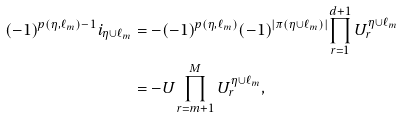<formula> <loc_0><loc_0><loc_500><loc_500>( - 1 ) ^ { p ( \eta , \ell _ { m } ) - 1 } i _ { \eta \cup \ell _ { m } } & = - ( - 1 ) ^ { p ( \eta , \ell _ { m } ) } ( - 1 ) ^ { | \pi ( \eta \cup \ell _ { m } ) | } { \prod _ { r = 1 } ^ { d + 1 } U ^ { \eta \cup \ell _ { m } } _ { r } } \\ & = - U { \prod _ { r = m + 1 } ^ { M } U ^ { \eta \cup \ell _ { m } } _ { r } } ,</formula> 